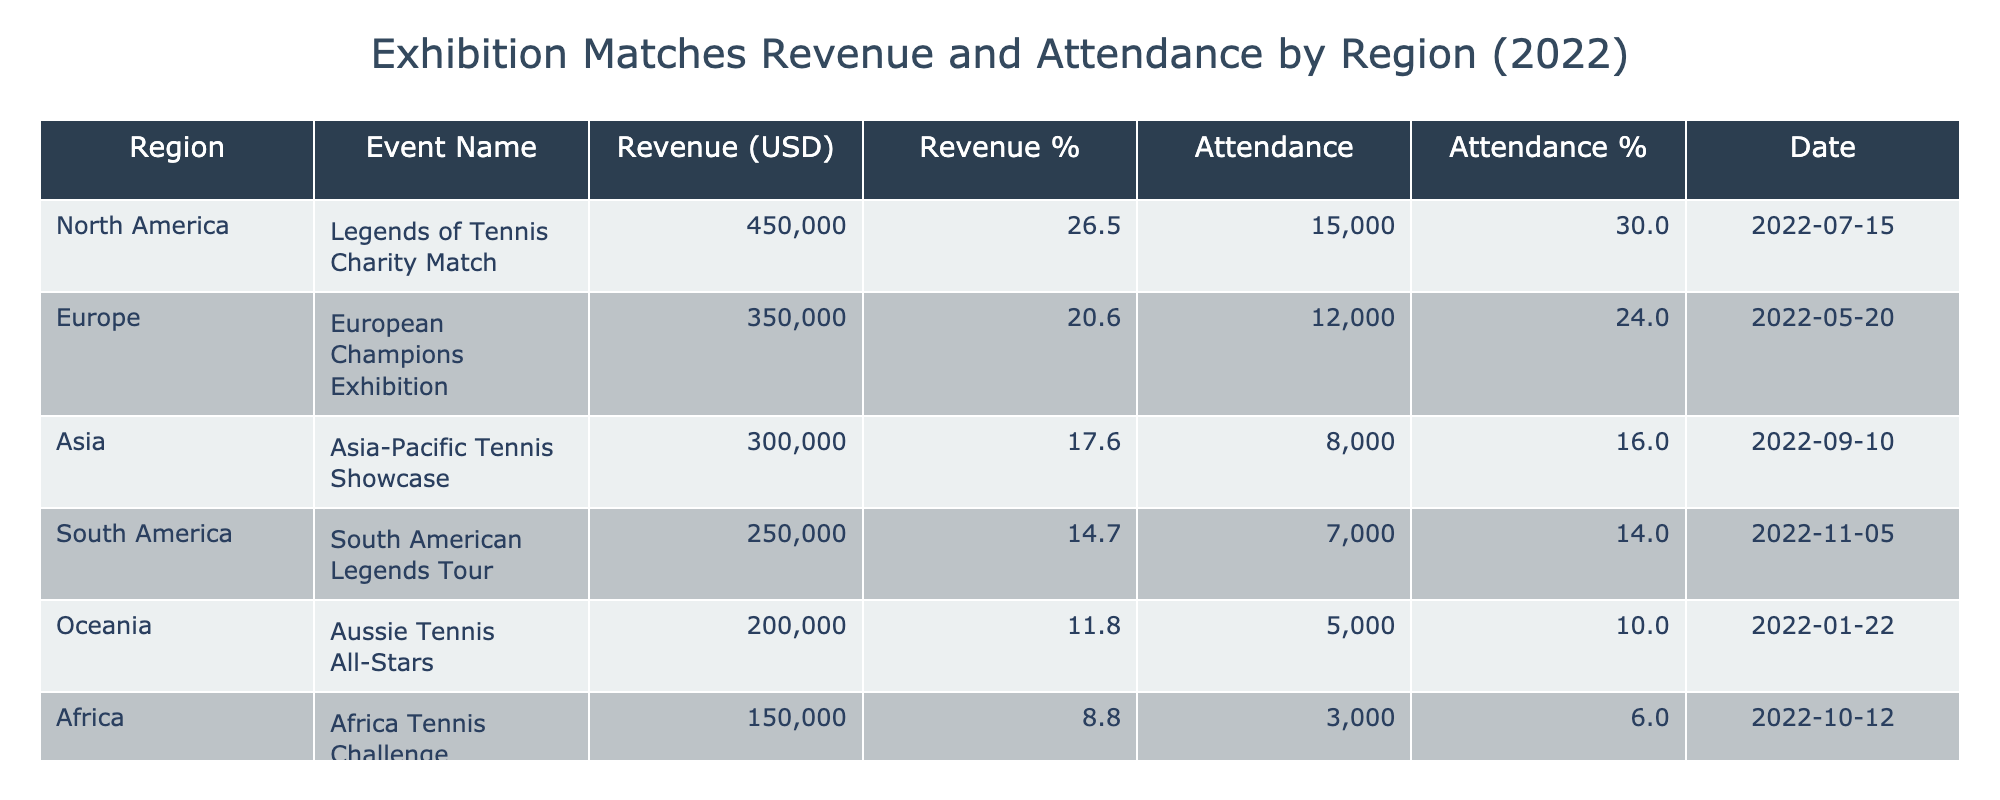What region generated the highest revenue from exhibition matches in 2022? North America generated the highest revenue with 450,000 USD from the Legends of Tennis Charity Match.
Answer: North America What percentage of the total revenue did Asia contribute? The total revenue from all matches is 2,000,000 USD. Asia contributed 300,000 USD, which is 300,000 / 2,000,000 * 100 = 15%.
Answer: 15% Which event had the lowest attendance? The Africa Tennis Challenge had the lowest attendance with 3,000 attendees.
Answer: Africa Tennis Challenge What was the average revenue per match across all regions? The total revenue is 2,000,000 USD from 6 events, so the average revenue per match is 2,000,000 / 6 = 333,333.33 USD.
Answer: 333,333.33 USD Did Oceania have a higher revenue percentage compared to South America? Oceania generated 200,000 USD, which is 10% of the total revenue. South America generated 250,000 USD, which is 12.5%. Therefore, Oceania did not have a higher percentage.
Answer: No Which region had the highest attendance and how much was it? North America had the highest attendance with 15,000 attendees from the Legends of Tennis Charity Match.
Answer: 15,000 What is the total attendance from all events in Europe and South America? The total attendance from Europe (12,000) and South America (7,000) is 12,000 + 7,000 = 19,000.
Answer: 19,000 How much more revenue did North America generate compared to Africa? North America generated 450,000 USD while Africa generated 150,000 USD. The difference is 450,000 - 150,000 = 300,000 USD.
Answer: 300,000 USD In which region was the event held on the latest date? The South American Legends Tour was held on November 5, 2022, which is the latest date compared to other events listed.
Answer: South America 